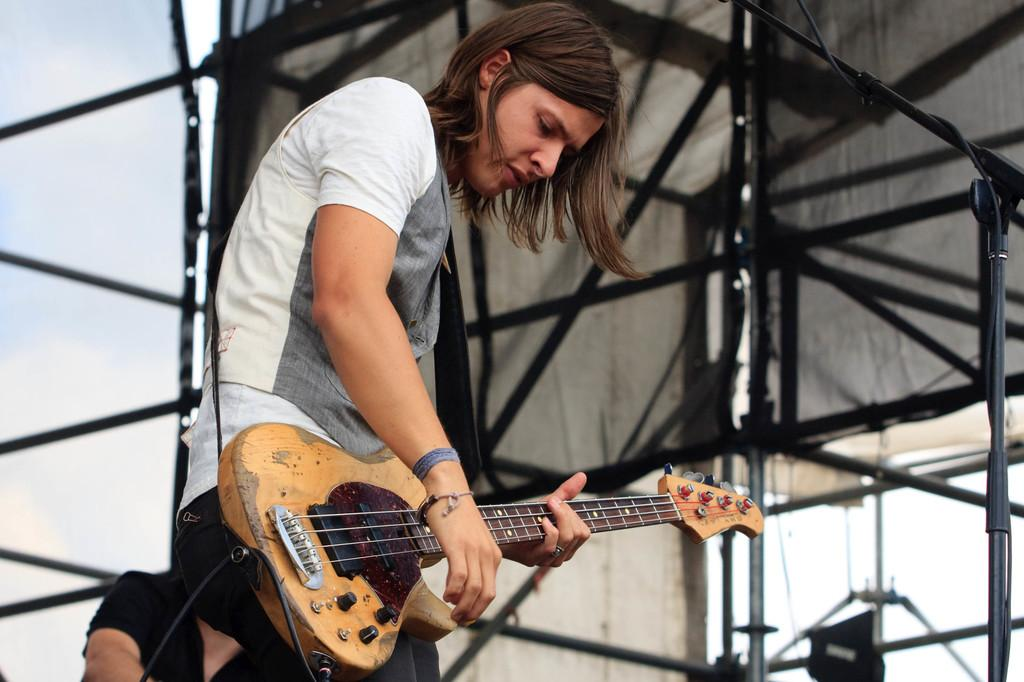What is the main subject of the image? There is a person in the image. What is the person wearing? The person is wearing a white shirt. What is the person holding in the image? The person is holding a guitar. What is the person doing with the guitar? The person is moving the strings of the guitar. What can be seen in the background of the image? There is a huge banner and the sky visible in the background of the image. What type of whistle can be heard in the image? There is no whistle present in the image, and therefore no sound can be heard. Can you see any stars in the sky in the image? The sky is visible in the background of the image, but there is no mention of stars, so we cannot determine if any are present. 